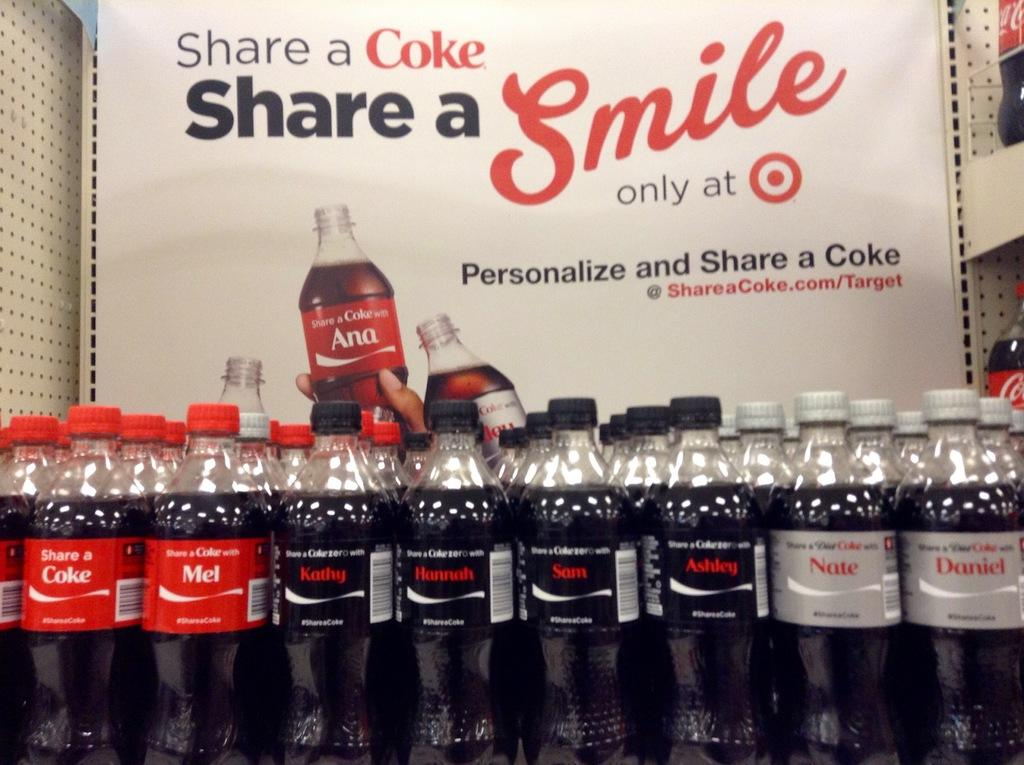<image>
Give a short and clear explanation of the subsequent image. A display at a Target store has Cokes with various names from Sam to Nate. 